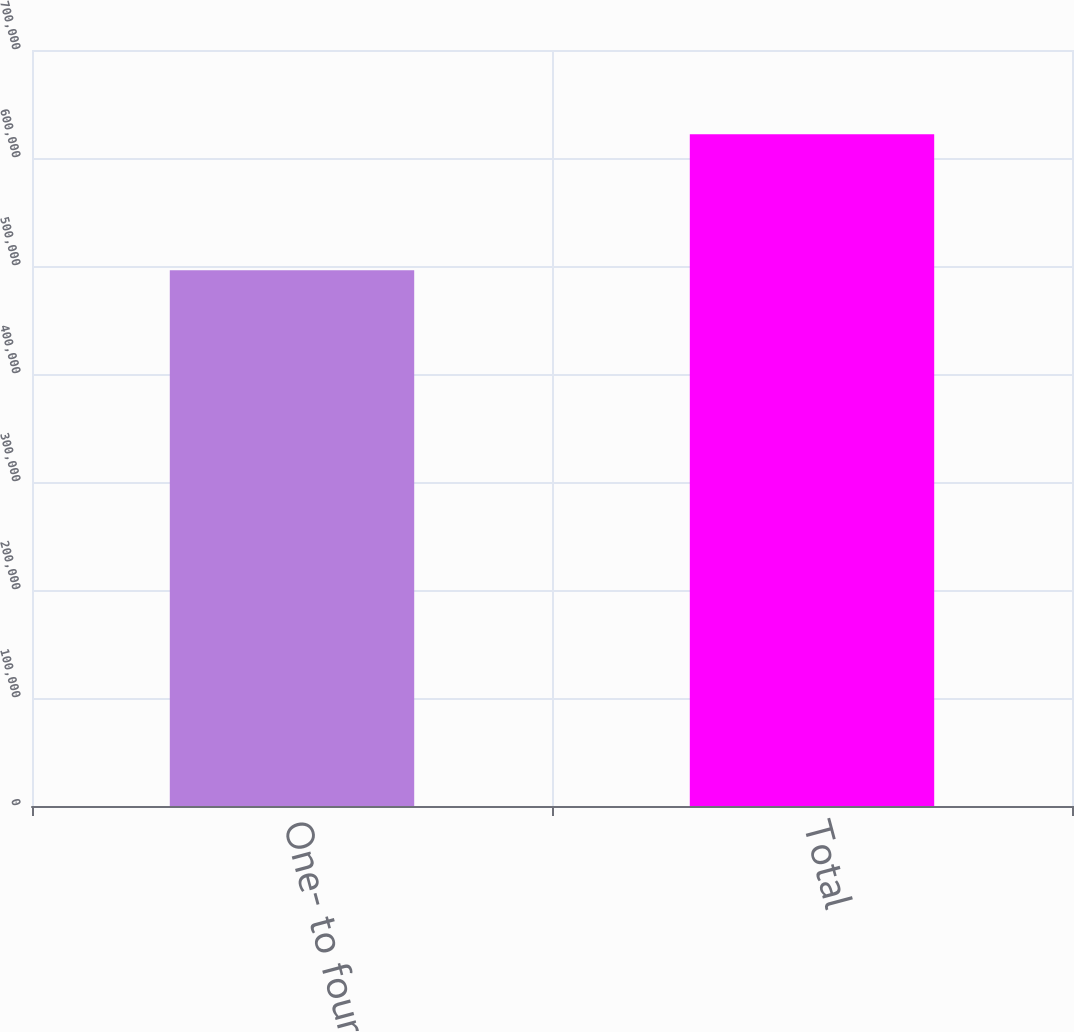Convert chart. <chart><loc_0><loc_0><loc_500><loc_500><bar_chart><fcel>One- to four-family<fcel>Total<nl><fcel>496136<fcel>622102<nl></chart> 